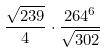Convert formula to latex. <formula><loc_0><loc_0><loc_500><loc_500>\frac { \sqrt { 2 3 9 } } { 4 } \cdot \frac { 2 6 4 ^ { 6 } } { \sqrt { 3 0 2 } }</formula> 